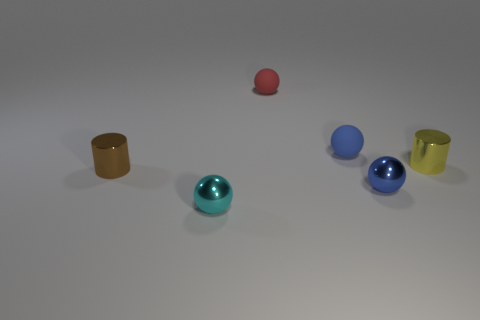Subtract all red matte spheres. How many spheres are left? 3 Subtract all red balls. How many balls are left? 3 Add 4 gray cylinders. How many objects exist? 10 Subtract all cylinders. How many objects are left? 4 Subtract 1 cylinders. How many cylinders are left? 1 Subtract all gray cylinders. Subtract all green cubes. How many cylinders are left? 2 Subtract all gray balls. How many cyan cylinders are left? 0 Subtract all small cyan objects. Subtract all cyan rubber objects. How many objects are left? 5 Add 3 tiny blue metallic spheres. How many tiny blue metallic spheres are left? 4 Add 4 small yellow objects. How many small yellow objects exist? 5 